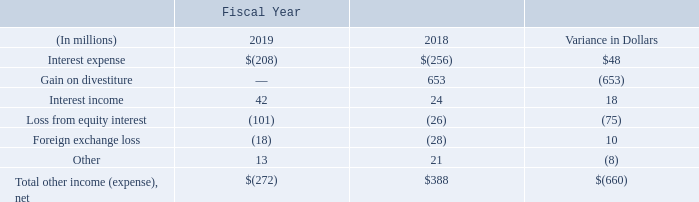Non-operating income (expense), net
Non-operating income (expense), net, decreased primarily due to the absence of the fiscal 2018 $653 million gain on the divestiture of our WSS and PKI solutions. In addition, our loss from our equity interest received in connection with the divestiture of our WSS and PKI solutions increased $75 million, which was partially offset by a $48 million decrease in interest expense as a result of lower outstanding borrowings due to repayments.
What does this table show? Non-operating income (expense), net. What was the primary reason for the decrease in Non-operating income (expense), net? The absence of the fiscal 2018 $653 million gain on the divestiture of our wss and pki solutions.  What was the Total other income (expense), net for fiscal year 2019? 
Answer scale should be: million. (272). What was the percentage change in income from fiscal 2018 to fiscal 2019?
Answer scale should be: percent. -660/388
Answer: -170.1. What was the total other income (expense), net for both fiscal years?
Answer scale should be: million. -272+388
Answer: 116. What is the average Total other income (expense), net for fiscal 2019 and fiscal 2018?
Answer scale should be: million. (-272+388)/2
Answer: 58. 